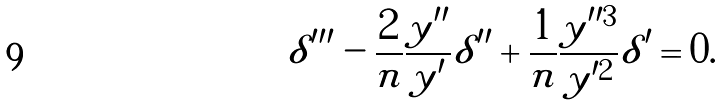Convert formula to latex. <formula><loc_0><loc_0><loc_500><loc_500>\delta ^ { \prime \prime \prime } - \frac { 2 } { n } \frac { y ^ { \prime \prime } } { y ^ { \prime } } \delta ^ { \prime \prime } + \frac { 1 } { n } \frac { y ^ { \prime \prime 3 } } { y ^ { \prime 2 } } \delta ^ { \prime } = 0 .</formula> 